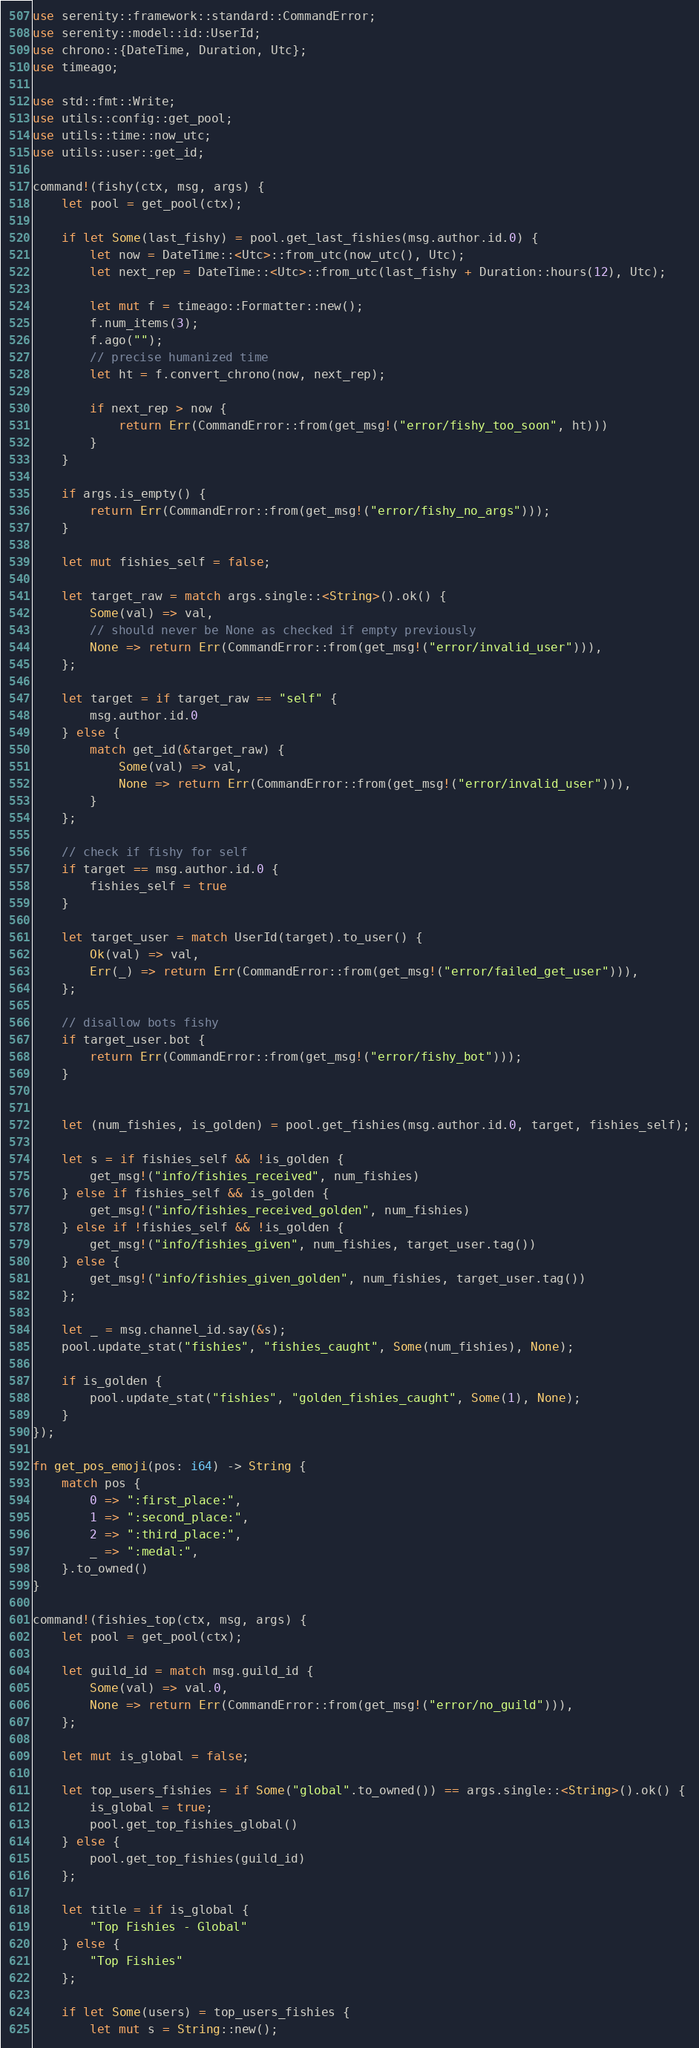Convert code to text. <code><loc_0><loc_0><loc_500><loc_500><_Rust_>use serenity::framework::standard::CommandError;
use serenity::model::id::UserId;
use chrono::{DateTime, Duration, Utc};
use timeago;

use std::fmt::Write;
use utils::config::get_pool;
use utils::time::now_utc;
use utils::user::get_id;

command!(fishy(ctx, msg, args) {
    let pool = get_pool(ctx);

    if let Some(last_fishy) = pool.get_last_fishies(msg.author.id.0) {
        let now = DateTime::<Utc>::from_utc(now_utc(), Utc);
        let next_rep = DateTime::<Utc>::from_utc(last_fishy + Duration::hours(12), Utc);

        let mut f = timeago::Formatter::new();
        f.num_items(3);
        f.ago("");
        // precise humanized time
        let ht = f.convert_chrono(now, next_rep);

        if next_rep > now {
            return Err(CommandError::from(get_msg!("error/fishy_too_soon", ht)))
        }
    }

    if args.is_empty() {
        return Err(CommandError::from(get_msg!("error/fishy_no_args")));
    }

    let mut fishies_self = false;

    let target_raw = match args.single::<String>().ok() {
        Some(val) => val,
        // should never be None as checked if empty previously
        None => return Err(CommandError::from(get_msg!("error/invalid_user"))),
    };

    let target = if target_raw == "self" {
        msg.author.id.0
    } else {
        match get_id(&target_raw) {
            Some(val) => val,
            None => return Err(CommandError::from(get_msg!("error/invalid_user"))),
        }
    };

    // check if fishy for self
    if target == msg.author.id.0 {
        fishies_self = true
    }

    let target_user = match UserId(target).to_user() {
        Ok(val) => val,
        Err(_) => return Err(CommandError::from(get_msg!("error/failed_get_user"))),
    };

    // disallow bots fishy
    if target_user.bot {
        return Err(CommandError::from(get_msg!("error/fishy_bot")));
    }


    let (num_fishies, is_golden) = pool.get_fishies(msg.author.id.0, target, fishies_self);

    let s = if fishies_self && !is_golden {
        get_msg!("info/fishies_received", num_fishies)
    } else if fishies_self && is_golden {
        get_msg!("info/fishies_received_golden", num_fishies)        
    } else if !fishies_self && !is_golden {
        get_msg!("info/fishies_given", num_fishies, target_user.tag())
    } else {
        get_msg!("info/fishies_given_golden", num_fishies, target_user.tag())
    };

    let _ = msg.channel_id.say(&s);
    pool.update_stat("fishies", "fishies_caught", Some(num_fishies), None);

    if is_golden {
        pool.update_stat("fishies", "golden_fishies_caught", Some(1), None);
    }
});

fn get_pos_emoji(pos: i64) -> String {
    match pos {
        0 => ":first_place:",
        1 => ":second_place:",
        2 => ":third_place:",
        _ => ":medal:",
    }.to_owned()
}

command!(fishies_top(ctx, msg, args) {
    let pool = get_pool(ctx);

    let guild_id = match msg.guild_id {
        Some(val) => val.0,
        None => return Err(CommandError::from(get_msg!("error/no_guild"))),
    };

    let mut is_global = false;

    let top_users_fishies = if Some("global".to_owned()) == args.single::<String>().ok() {
        is_global = true;
        pool.get_top_fishies_global()
    } else {
        pool.get_top_fishies(guild_id)
    };

    let title = if is_global {
        "Top Fishies - Global"
    } else {
        "Top Fishies"
    };
    
    if let Some(users) = top_users_fishies {
        let mut s = String::new();
</code> 